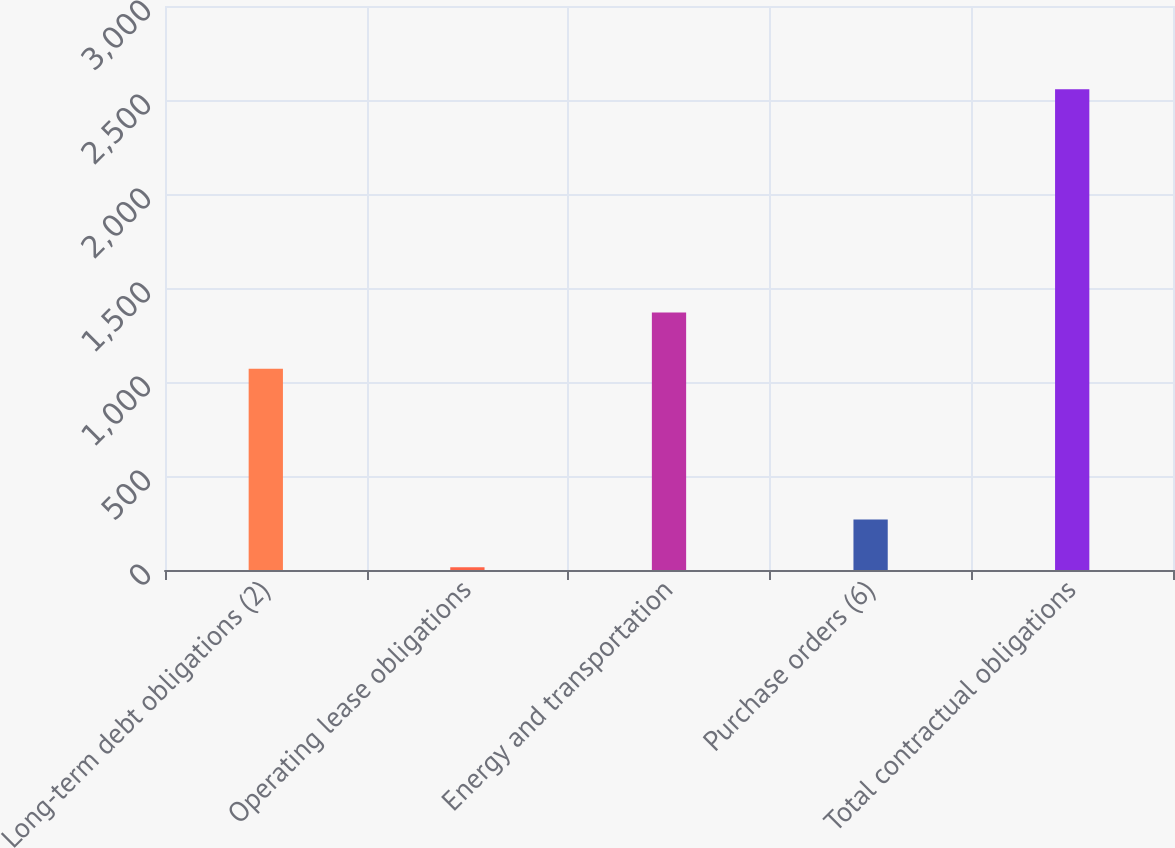Convert chart to OTSL. <chart><loc_0><loc_0><loc_500><loc_500><bar_chart><fcel>Long-term debt obligations (2)<fcel>Operating lease obligations<fcel>Energy and transportation<fcel>Purchase orders (6)<fcel>Total contractual obligations<nl><fcel>1070.5<fcel>14.7<fcel>1369.7<fcel>268.97<fcel>2557.4<nl></chart> 